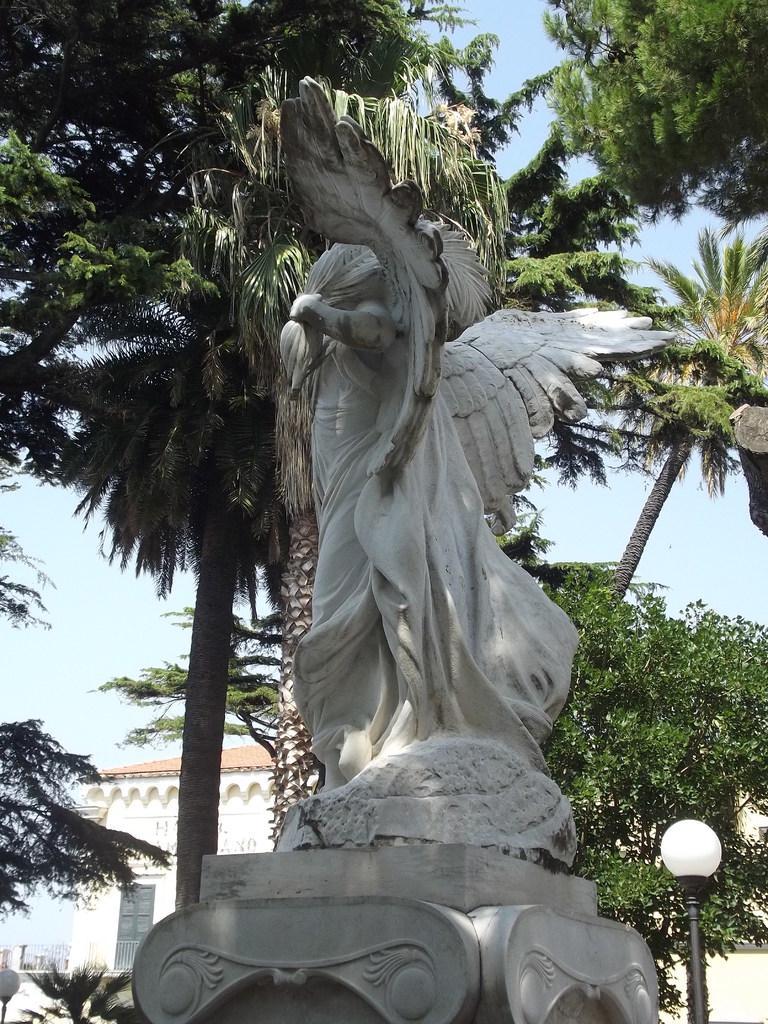Describe this image in one or two sentences. In the image there is a statue in the middle with a street light beside it and behind there are trees, followed by buildings in the background and above its sky. 